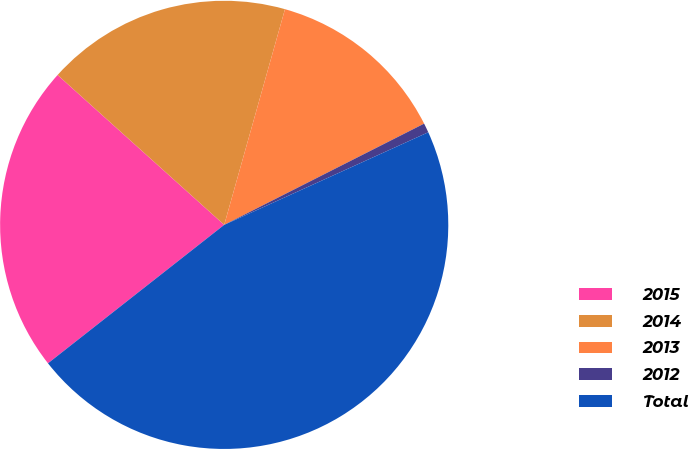<chart> <loc_0><loc_0><loc_500><loc_500><pie_chart><fcel>2015<fcel>2014<fcel>2013<fcel>2012<fcel>Total<nl><fcel>22.26%<fcel>17.71%<fcel>13.17%<fcel>0.68%<fcel>46.18%<nl></chart> 